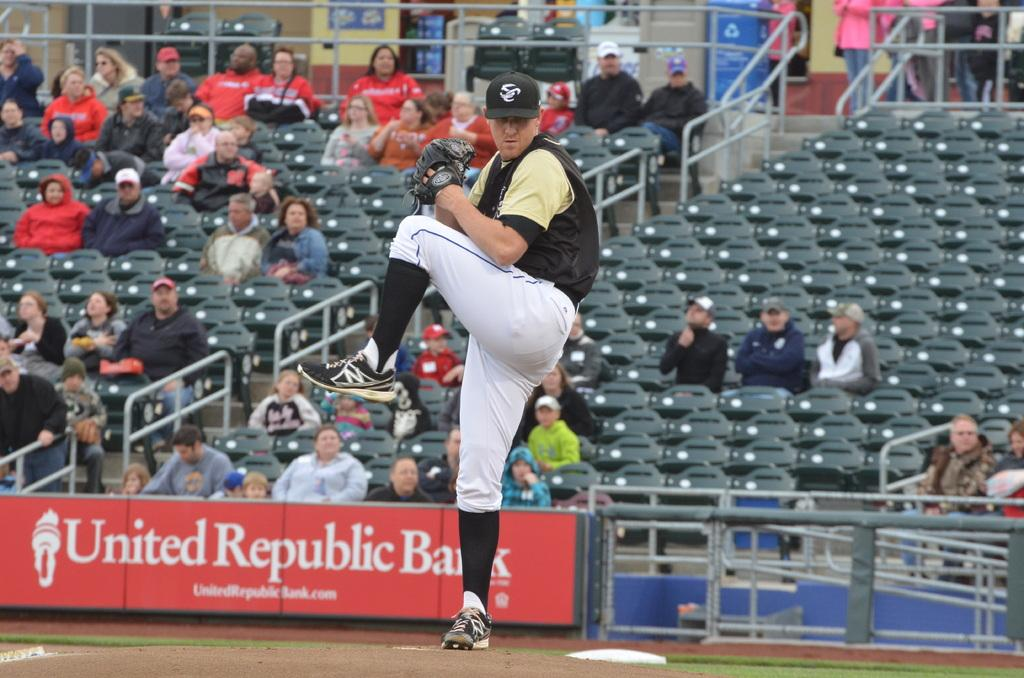<image>
Create a compact narrative representing the image presented. A baseball player infront of a United Republic Bank banner 